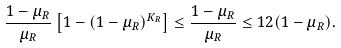<formula> <loc_0><loc_0><loc_500><loc_500>\frac { 1 - \mu _ { R } } { \mu _ { R } } \left [ 1 - ( 1 - \mu _ { R } ) ^ { K _ { R } } \right ] \leq \frac { 1 - \mu _ { R } } { \mu _ { R } } \leq 1 2 ( 1 - \mu _ { R } ) .</formula> 